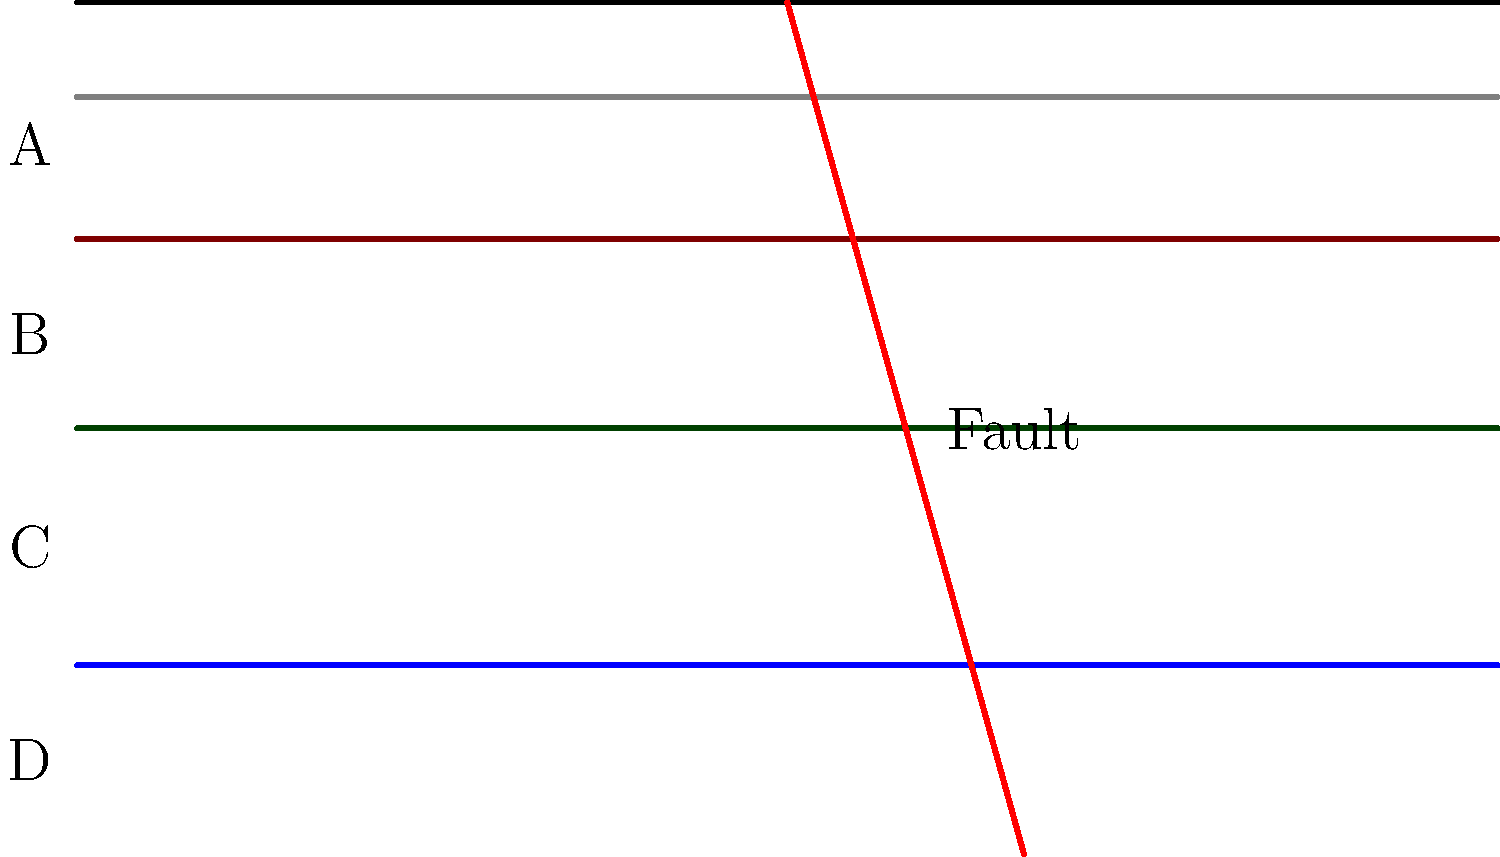In the geological cross-section shown above, identify the type of fault present and explain how it has affected the rock layers. To identify the fault type and its effect on the rock layers, let's analyze the cross-section step-by-step:

1. Observe the orientation of the fault line:
   The fault line is diagonal, sloping from left to right.

2. Compare the position of rock layers on either side of the fault:
   The rock layers on the right side of the fault are lower than their counterparts on the left side.

3. Identify the fault type:
   This is a normal fault. In a normal fault, the hanging wall (right side) moves downward relative to the footwall (left side).

4. Understand the cause:
   Normal faults are typically caused by tensional forces that stretch the crust.

5. Analyze the effect on rock layers:
   - The fault has displaced the rock layers vertically.
   - Layers A, B, C, and D are continuous on the left side of the fault.
   - On the right side, these layers are shifted downward.
   - This displacement has caused the layers to be discontinuous across the fault line.

6. Consider the implications:
   - The fault movement has exposed older rock layers (C and D) on the left side that are buried deeper on the right side.
   - This creates a situation where different aged rocks are adjacent to each other across the fault line.

As a former student of Martin Schoell, you might recall discussing how such faults can impact hydrocarbon migration and trapping in sedimentary basins.
Answer: Normal fault; downward displacement of rock layers on the right side. 